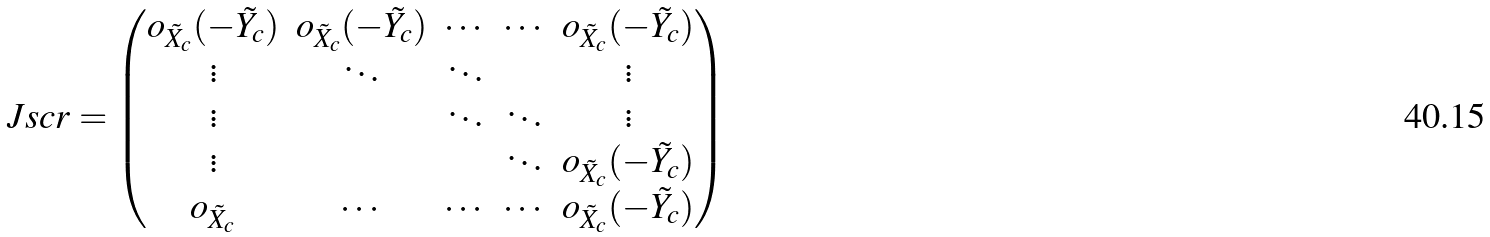Convert formula to latex. <formula><loc_0><loc_0><loc_500><loc_500>\ J s c r = \begin{pmatrix} o _ { \tilde { X } _ { c } } ( - \tilde { Y _ { c } } ) & o _ { \tilde { X } _ { c } } ( - \tilde { Y _ { c } } ) & \cdots & \cdots & o _ { \tilde { X } _ { c } } ( - \tilde { Y _ { c } } ) \\ \vdots & \ddots & \ddots & & \vdots \\ \vdots & & \ddots & \ddots & \vdots \\ \vdots & & & \ddots & o _ { \tilde { X } _ { c } } ( - \tilde { Y _ { c } } ) \\ o _ { \tilde { X } _ { c } } & \cdots & \cdots & \cdots & o _ { \tilde { X } _ { c } } ( - \tilde { Y _ { c } } ) \end{pmatrix}</formula> 